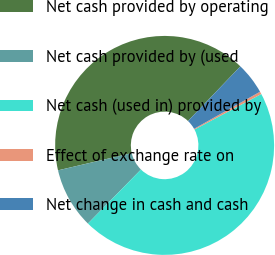Convert chart to OTSL. <chart><loc_0><loc_0><loc_500><loc_500><pie_chart><fcel>Net cash provided by operating<fcel>Net cash provided by (used<fcel>Net cash (used in) provided by<fcel>Effect of exchange rate on<fcel>Net change in cash and cash<nl><fcel>40.82%<fcel>8.99%<fcel>45.13%<fcel>0.38%<fcel>4.68%<nl></chart> 